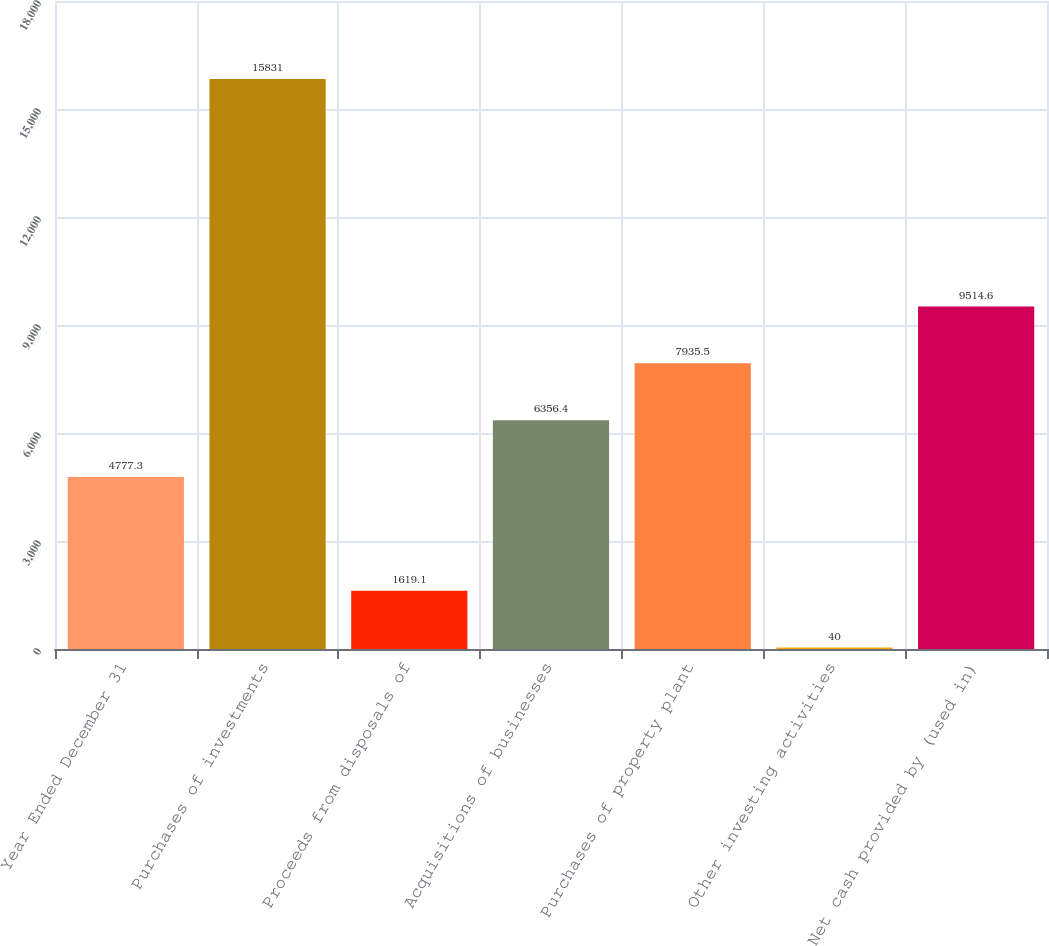<chart> <loc_0><loc_0><loc_500><loc_500><bar_chart><fcel>Year Ended December 31<fcel>Purchases of investments<fcel>Proceeds from disposals of<fcel>Acquisitions of businesses<fcel>Purchases of property plant<fcel>Other investing activities<fcel>Net cash provided by (used in)<nl><fcel>4777.3<fcel>15831<fcel>1619.1<fcel>6356.4<fcel>7935.5<fcel>40<fcel>9514.6<nl></chart> 